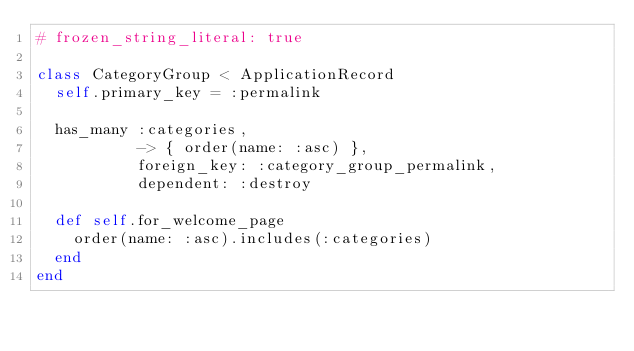<code> <loc_0><loc_0><loc_500><loc_500><_Ruby_># frozen_string_literal: true

class CategoryGroup < ApplicationRecord
  self.primary_key = :permalink

  has_many :categories,
           -> { order(name: :asc) },
           foreign_key: :category_group_permalink,
           dependent: :destroy

  def self.for_welcome_page
    order(name: :asc).includes(:categories)
  end
end
</code> 